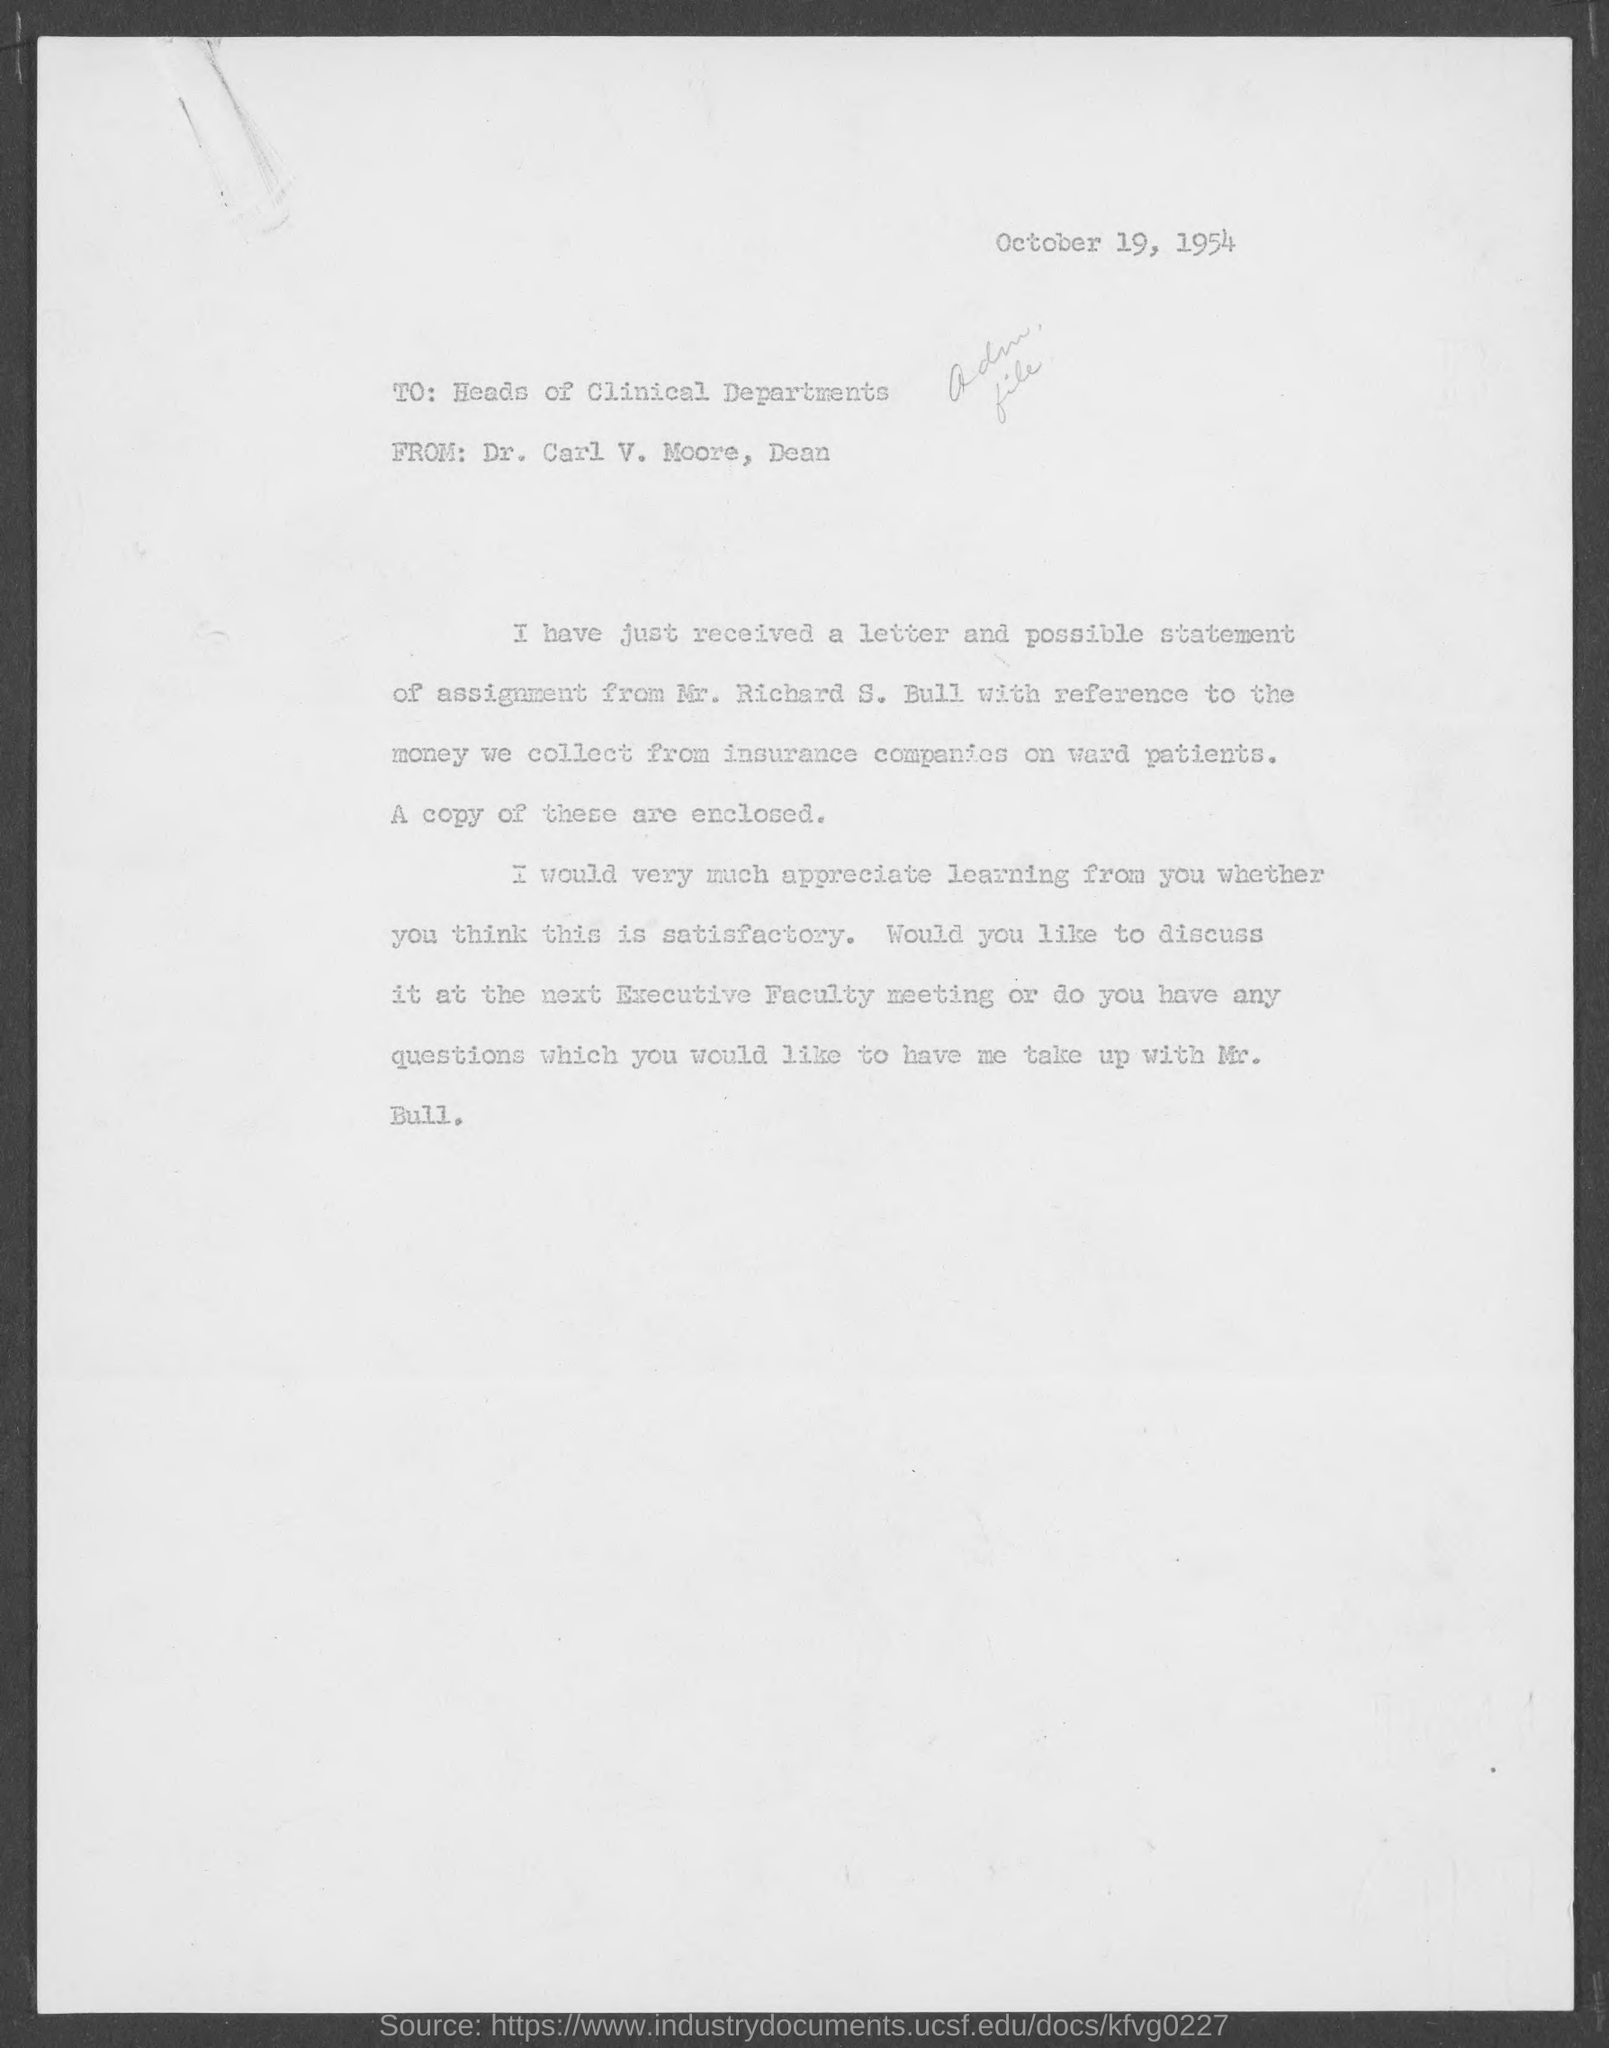Point out several critical features in this image. The letter was dated October 19, 1954. Carl V. Moore is the dean. 